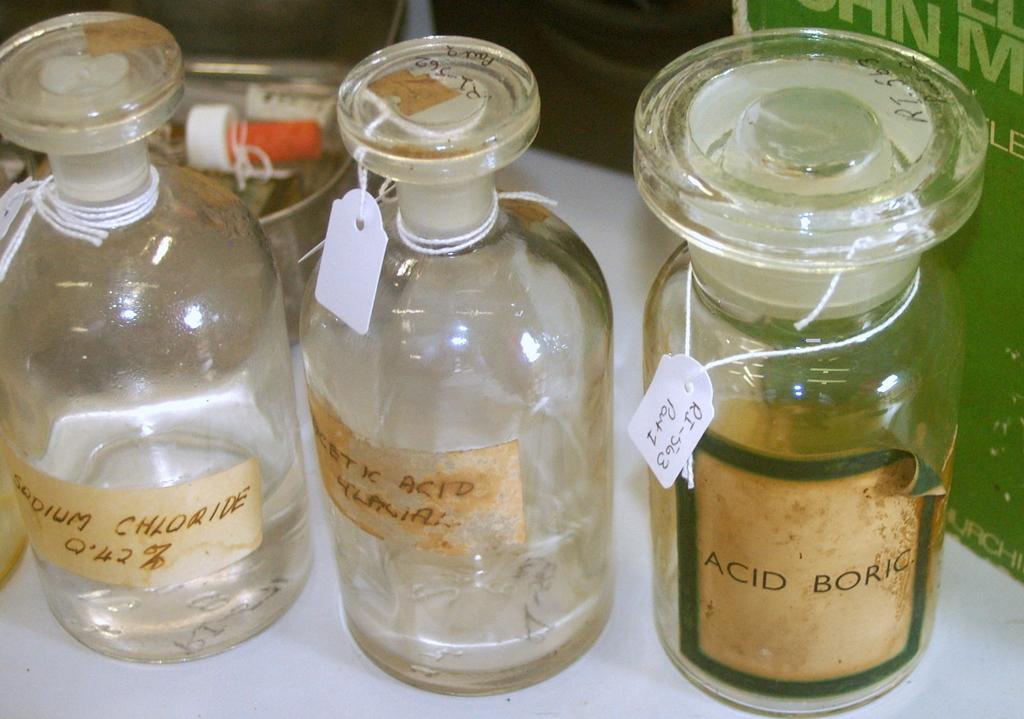Describe this image in one or two sentences. Here we see bottles on the table 